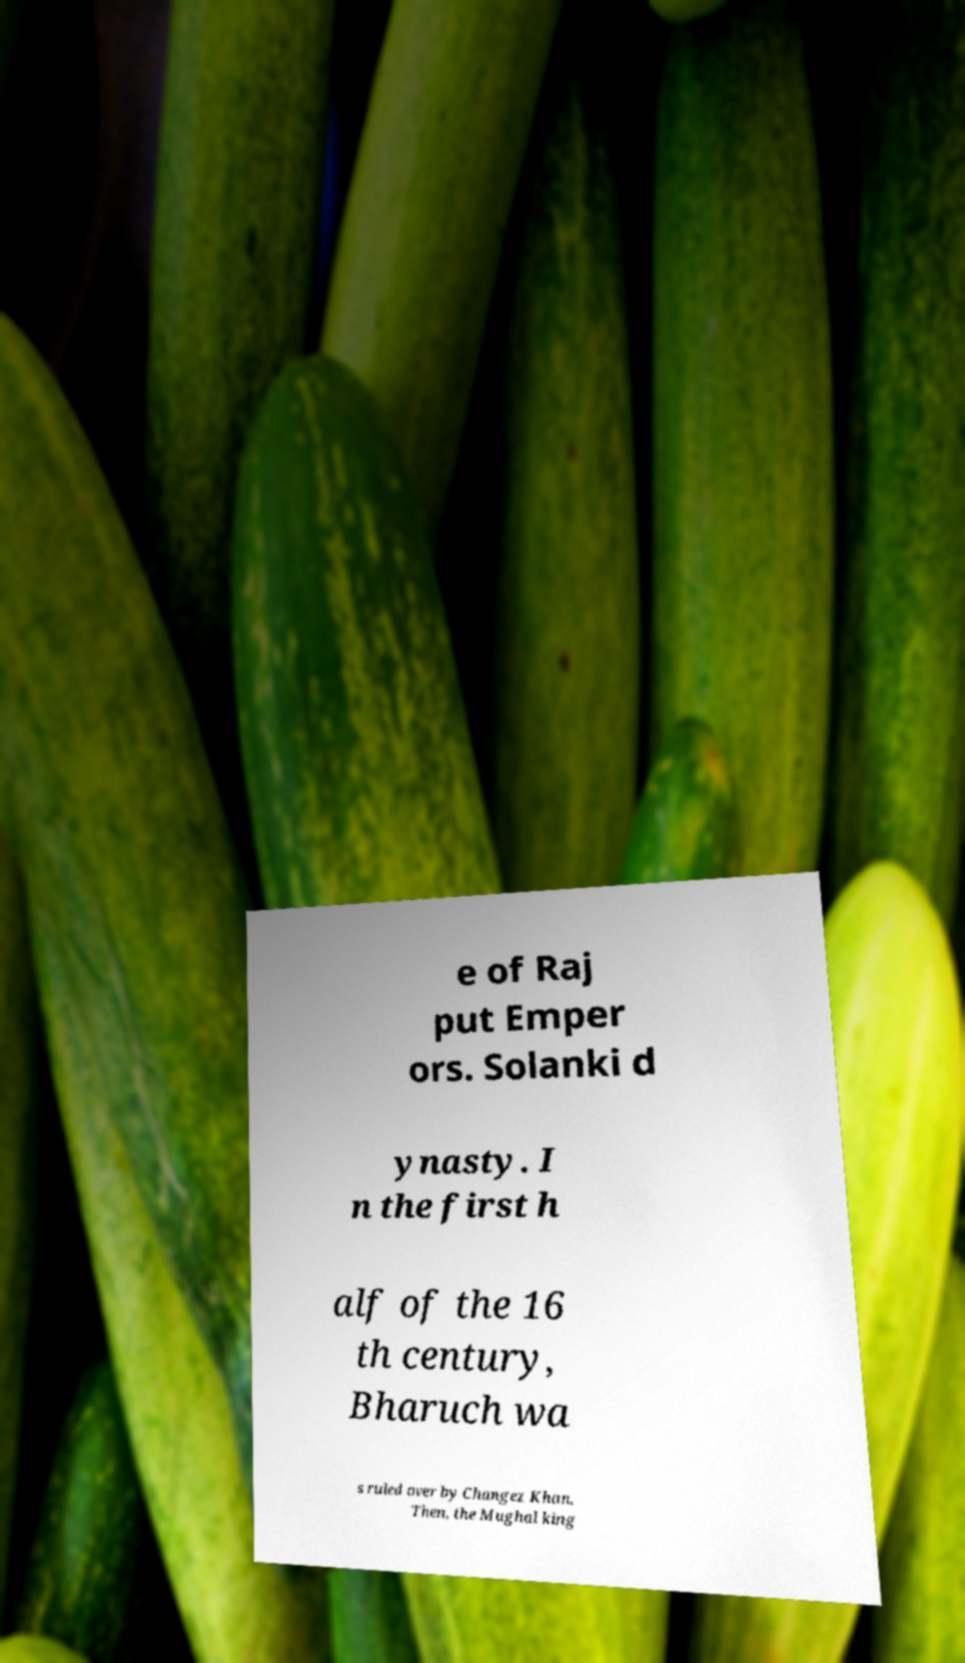I need the written content from this picture converted into text. Can you do that? e of Raj put Emper ors. Solanki d ynasty. I n the first h alf of the 16 th century, Bharuch wa s ruled over by Changez Khan. Then, the Mughal king 